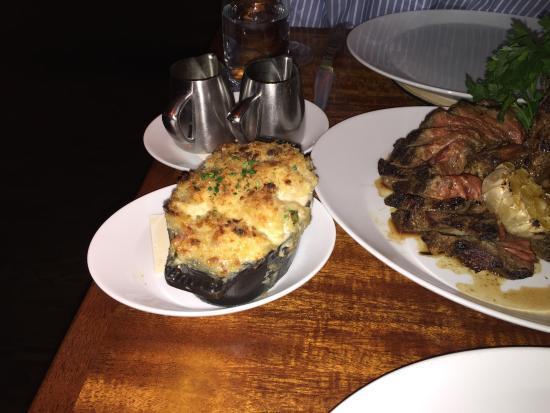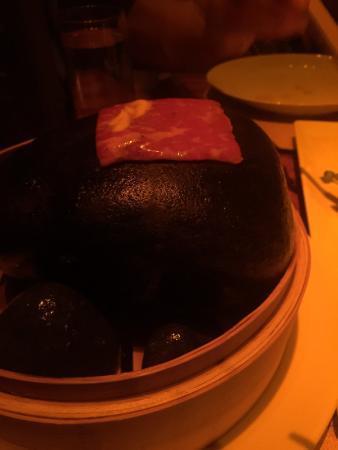The first image is the image on the left, the second image is the image on the right. Analyze the images presented: Is the assertion "In at least one image there is a bamboo bowl holding hot stones and topped with chopsticks." valid? Answer yes or no. No. 